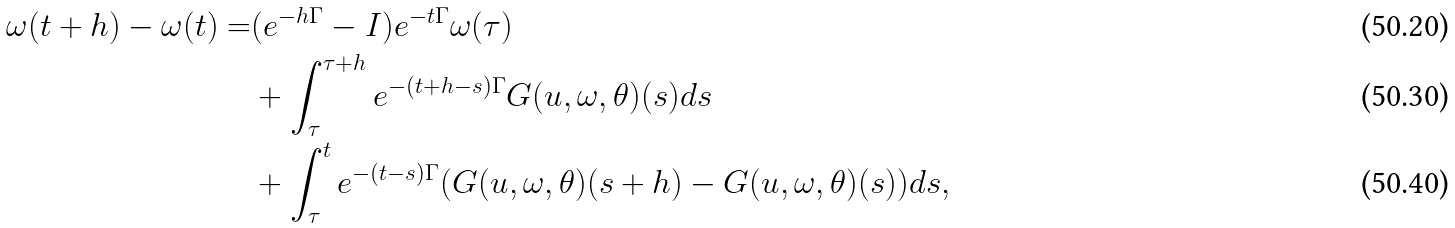Convert formula to latex. <formula><loc_0><loc_0><loc_500><loc_500>\omega ( t + h ) - \omega ( t ) = & ( e ^ { - h \Gamma } - I ) e ^ { - t \Gamma } \omega ( \tau ) \\ & + \int ^ { \tau + h } _ { \tau } e ^ { - ( t + h - s ) \Gamma } G ( u , \omega , \theta ) ( s ) d s \\ & + \int ^ { t } _ { \tau } e ^ { - ( t - s ) \Gamma } ( G ( u , \omega , \theta ) ( s + h ) - G ( u , \omega , \theta ) ( s ) ) d s ,</formula> 